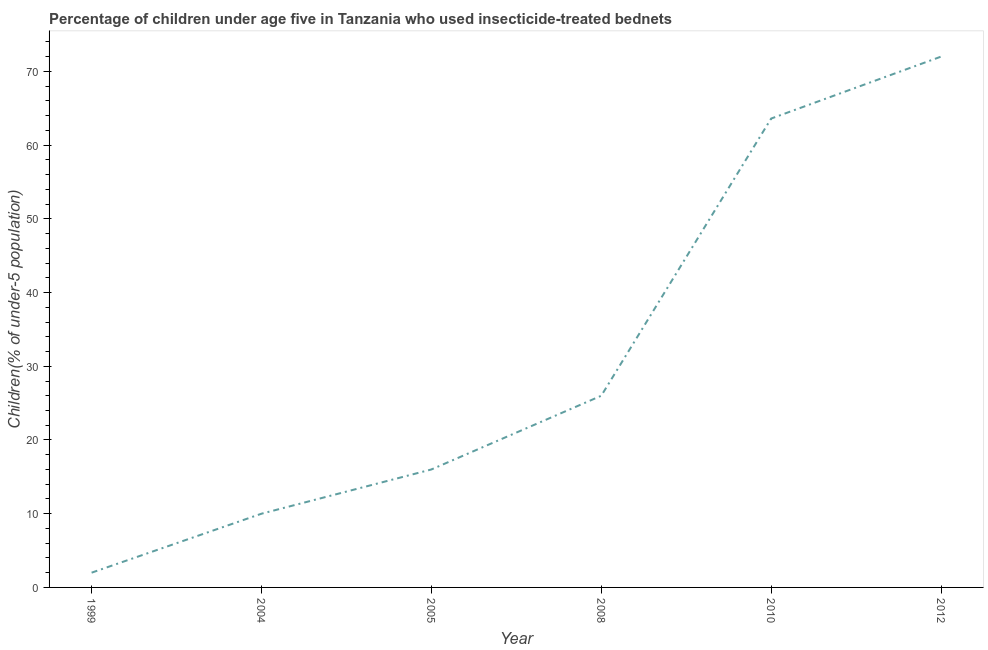What is the percentage of children who use of insecticide-treated bed nets in 2012?
Your answer should be very brief. 72. In which year was the percentage of children who use of insecticide-treated bed nets maximum?
Your answer should be compact. 2012. In which year was the percentage of children who use of insecticide-treated bed nets minimum?
Provide a short and direct response. 1999. What is the sum of the percentage of children who use of insecticide-treated bed nets?
Offer a very short reply. 189.6. What is the difference between the percentage of children who use of insecticide-treated bed nets in 2004 and 2008?
Your answer should be compact. -16. What is the average percentage of children who use of insecticide-treated bed nets per year?
Your response must be concise. 31.6. What is the median percentage of children who use of insecticide-treated bed nets?
Your answer should be compact. 21. In how many years, is the percentage of children who use of insecticide-treated bed nets greater than 16 %?
Offer a terse response. 3. What is the ratio of the percentage of children who use of insecticide-treated bed nets in 2005 to that in 2012?
Your answer should be compact. 0.22. What is the difference between the highest and the second highest percentage of children who use of insecticide-treated bed nets?
Ensure brevity in your answer.  8.4. In how many years, is the percentage of children who use of insecticide-treated bed nets greater than the average percentage of children who use of insecticide-treated bed nets taken over all years?
Make the answer very short. 2. How many years are there in the graph?
Keep it short and to the point. 6. Does the graph contain grids?
Ensure brevity in your answer.  No. What is the title of the graph?
Provide a short and direct response. Percentage of children under age five in Tanzania who used insecticide-treated bednets. What is the label or title of the X-axis?
Give a very brief answer. Year. What is the label or title of the Y-axis?
Offer a very short reply. Children(% of under-5 population). What is the Children(% of under-5 population) of 1999?
Keep it short and to the point. 2. What is the Children(% of under-5 population) in 2004?
Your response must be concise. 10. What is the Children(% of under-5 population) of 2005?
Your answer should be very brief. 16. What is the Children(% of under-5 population) in 2010?
Your answer should be compact. 63.6. What is the Children(% of under-5 population) in 2012?
Offer a terse response. 72. What is the difference between the Children(% of under-5 population) in 1999 and 2004?
Your answer should be compact. -8. What is the difference between the Children(% of under-5 population) in 1999 and 2010?
Your answer should be compact. -61.6. What is the difference between the Children(% of under-5 population) in 1999 and 2012?
Keep it short and to the point. -70. What is the difference between the Children(% of under-5 population) in 2004 and 2008?
Your answer should be compact. -16. What is the difference between the Children(% of under-5 population) in 2004 and 2010?
Keep it short and to the point. -53.6. What is the difference between the Children(% of under-5 population) in 2004 and 2012?
Ensure brevity in your answer.  -62. What is the difference between the Children(% of under-5 population) in 2005 and 2010?
Your answer should be very brief. -47.6. What is the difference between the Children(% of under-5 population) in 2005 and 2012?
Offer a very short reply. -56. What is the difference between the Children(% of under-5 population) in 2008 and 2010?
Offer a terse response. -37.6. What is the difference between the Children(% of under-5 population) in 2008 and 2012?
Provide a short and direct response. -46. What is the difference between the Children(% of under-5 population) in 2010 and 2012?
Your response must be concise. -8.4. What is the ratio of the Children(% of under-5 population) in 1999 to that in 2005?
Keep it short and to the point. 0.12. What is the ratio of the Children(% of under-5 population) in 1999 to that in 2008?
Offer a very short reply. 0.08. What is the ratio of the Children(% of under-5 population) in 1999 to that in 2010?
Offer a terse response. 0.03. What is the ratio of the Children(% of under-5 population) in 1999 to that in 2012?
Keep it short and to the point. 0.03. What is the ratio of the Children(% of under-5 population) in 2004 to that in 2008?
Keep it short and to the point. 0.39. What is the ratio of the Children(% of under-5 population) in 2004 to that in 2010?
Your answer should be compact. 0.16. What is the ratio of the Children(% of under-5 population) in 2004 to that in 2012?
Keep it short and to the point. 0.14. What is the ratio of the Children(% of under-5 population) in 2005 to that in 2008?
Your answer should be compact. 0.61. What is the ratio of the Children(% of under-5 population) in 2005 to that in 2010?
Provide a succinct answer. 0.25. What is the ratio of the Children(% of under-5 population) in 2005 to that in 2012?
Give a very brief answer. 0.22. What is the ratio of the Children(% of under-5 population) in 2008 to that in 2010?
Your answer should be very brief. 0.41. What is the ratio of the Children(% of under-5 population) in 2008 to that in 2012?
Give a very brief answer. 0.36. What is the ratio of the Children(% of under-5 population) in 2010 to that in 2012?
Offer a terse response. 0.88. 